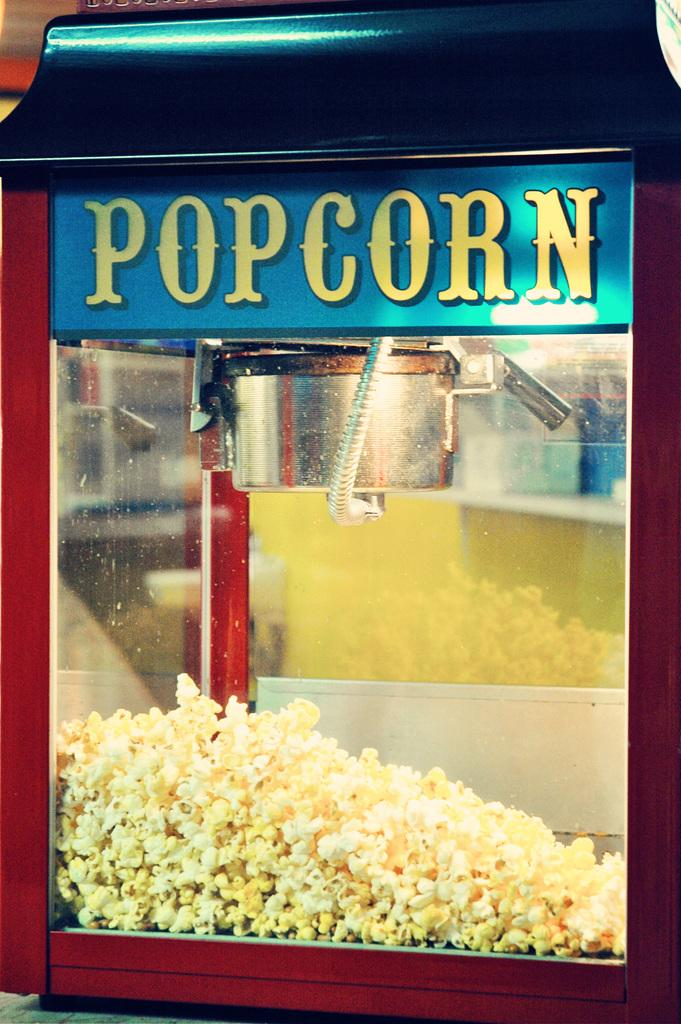<image>
Write a terse but informative summary of the picture. A popcorn dispenser is seen close up, about a quarter full. 